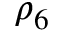<formula> <loc_0><loc_0><loc_500><loc_500>\rho _ { 6 }</formula> 